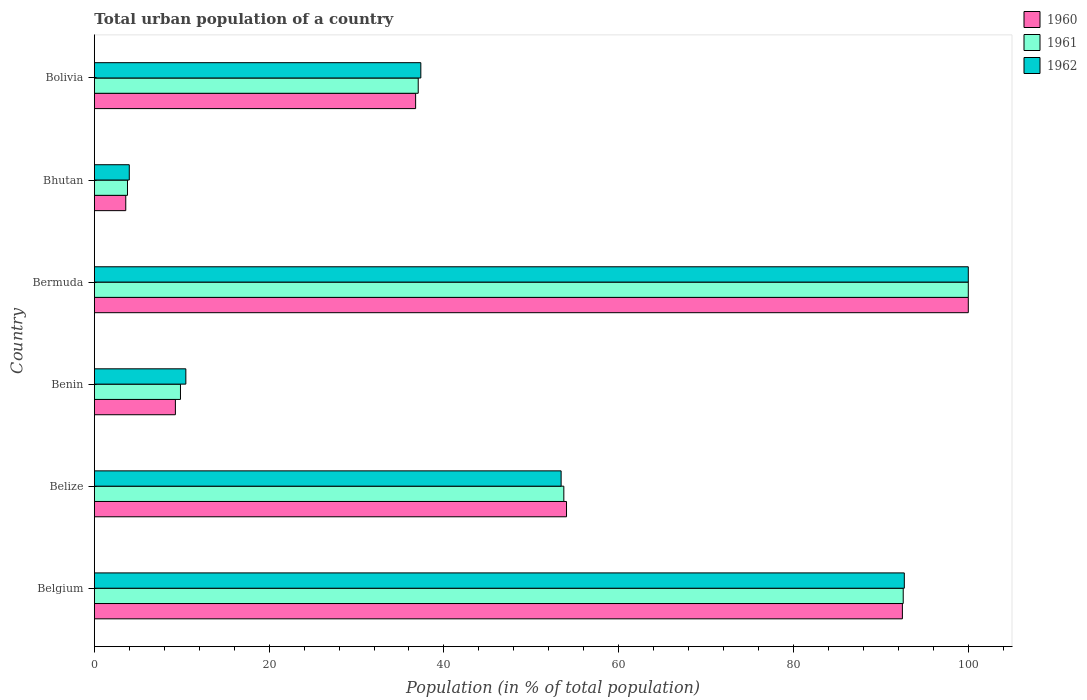How many different coloured bars are there?
Your answer should be very brief. 3. How many groups of bars are there?
Give a very brief answer. 6. Are the number of bars per tick equal to the number of legend labels?
Offer a terse response. Yes. Are the number of bars on each tick of the Y-axis equal?
Offer a very short reply. Yes. What is the label of the 4th group of bars from the top?
Make the answer very short. Benin. What is the urban population in 1961 in Belgium?
Ensure brevity in your answer.  92.55. Across all countries, what is the maximum urban population in 1960?
Your answer should be compact. 100. Across all countries, what is the minimum urban population in 1961?
Keep it short and to the point. 3.79. In which country was the urban population in 1960 maximum?
Give a very brief answer. Bermuda. In which country was the urban population in 1962 minimum?
Provide a short and direct response. Bhutan. What is the total urban population in 1960 in the graph?
Your answer should be very brief. 296.12. What is the difference between the urban population in 1962 in Belgium and that in Belize?
Make the answer very short. 39.27. What is the difference between the urban population in 1960 in Bolivia and the urban population in 1961 in Benin?
Offer a very short reply. 26.91. What is the average urban population in 1960 per country?
Keep it short and to the point. 49.35. What is the difference between the urban population in 1961 and urban population in 1960 in Belize?
Offer a terse response. -0.31. What is the ratio of the urban population in 1962 in Benin to that in Bolivia?
Your response must be concise. 0.28. Is the urban population in 1960 in Belgium less than that in Bhutan?
Offer a very short reply. No. What is the difference between the highest and the second highest urban population in 1962?
Your answer should be very brief. 7.32. What is the difference between the highest and the lowest urban population in 1961?
Your answer should be very brief. 96.21. In how many countries, is the urban population in 1960 greater than the average urban population in 1960 taken over all countries?
Keep it short and to the point. 3. Is the sum of the urban population in 1961 in Belize and Benin greater than the maximum urban population in 1962 across all countries?
Keep it short and to the point. No. What does the 1st bar from the top in Bhutan represents?
Offer a very short reply. 1962. Is it the case that in every country, the sum of the urban population in 1961 and urban population in 1962 is greater than the urban population in 1960?
Your answer should be very brief. Yes. How many bars are there?
Your response must be concise. 18. How many countries are there in the graph?
Provide a short and direct response. 6. What is the difference between two consecutive major ticks on the X-axis?
Provide a short and direct response. 20. Does the graph contain grids?
Provide a succinct answer. No. Where does the legend appear in the graph?
Offer a very short reply. Top right. How are the legend labels stacked?
Offer a terse response. Vertical. What is the title of the graph?
Your answer should be compact. Total urban population of a country. What is the label or title of the X-axis?
Make the answer very short. Population (in % of total population). What is the label or title of the Y-axis?
Ensure brevity in your answer.  Country. What is the Population (in % of total population) of 1960 in Belgium?
Keep it short and to the point. 92.46. What is the Population (in % of total population) of 1961 in Belgium?
Ensure brevity in your answer.  92.55. What is the Population (in % of total population) of 1962 in Belgium?
Ensure brevity in your answer.  92.68. What is the Population (in % of total population) in 1960 in Belize?
Your response must be concise. 54.03. What is the Population (in % of total population) in 1961 in Belize?
Give a very brief answer. 53.72. What is the Population (in % of total population) in 1962 in Belize?
Your answer should be compact. 53.41. What is the Population (in % of total population) of 1960 in Benin?
Offer a terse response. 9.28. What is the Population (in % of total population) in 1961 in Benin?
Offer a terse response. 9.86. What is the Population (in % of total population) in 1962 in Benin?
Provide a succinct answer. 10.47. What is the Population (in % of total population) in 1961 in Bermuda?
Your answer should be compact. 100. What is the Population (in % of total population) of 1962 in Bermuda?
Offer a terse response. 100. What is the Population (in % of total population) of 1960 in Bhutan?
Make the answer very short. 3.6. What is the Population (in % of total population) of 1961 in Bhutan?
Provide a short and direct response. 3.79. What is the Population (in % of total population) in 1962 in Bhutan?
Your answer should be very brief. 4. What is the Population (in % of total population) in 1960 in Bolivia?
Offer a very short reply. 36.76. What is the Population (in % of total population) in 1961 in Bolivia?
Your response must be concise. 37.06. What is the Population (in % of total population) in 1962 in Bolivia?
Keep it short and to the point. 37.36. Across all countries, what is the maximum Population (in % of total population) of 1960?
Provide a succinct answer. 100. Across all countries, what is the maximum Population (in % of total population) of 1961?
Provide a succinct answer. 100. Across all countries, what is the maximum Population (in % of total population) of 1962?
Provide a succinct answer. 100. Across all countries, what is the minimum Population (in % of total population) of 1960?
Ensure brevity in your answer.  3.6. Across all countries, what is the minimum Population (in % of total population) of 1961?
Your response must be concise. 3.79. Across all countries, what is the minimum Population (in % of total population) of 1962?
Keep it short and to the point. 4. What is the total Population (in % of total population) in 1960 in the graph?
Provide a succinct answer. 296.12. What is the total Population (in % of total population) of 1961 in the graph?
Provide a succinct answer. 296.98. What is the total Population (in % of total population) in 1962 in the graph?
Offer a terse response. 297.92. What is the difference between the Population (in % of total population) of 1960 in Belgium and that in Belize?
Provide a short and direct response. 38.43. What is the difference between the Population (in % of total population) of 1961 in Belgium and that in Belize?
Your answer should be very brief. 38.83. What is the difference between the Population (in % of total population) of 1962 in Belgium and that in Belize?
Make the answer very short. 39.27. What is the difference between the Population (in % of total population) in 1960 in Belgium and that in Benin?
Give a very brief answer. 83.19. What is the difference between the Population (in % of total population) of 1961 in Belgium and that in Benin?
Ensure brevity in your answer.  82.7. What is the difference between the Population (in % of total population) of 1962 in Belgium and that in Benin?
Provide a short and direct response. 82.21. What is the difference between the Population (in % of total population) of 1960 in Belgium and that in Bermuda?
Offer a very short reply. -7.54. What is the difference between the Population (in % of total population) of 1961 in Belgium and that in Bermuda?
Offer a very short reply. -7.45. What is the difference between the Population (in % of total population) of 1962 in Belgium and that in Bermuda?
Provide a short and direct response. -7.32. What is the difference between the Population (in % of total population) in 1960 in Belgium and that in Bhutan?
Make the answer very short. 88.86. What is the difference between the Population (in % of total population) in 1961 in Belgium and that in Bhutan?
Your answer should be very brief. 88.76. What is the difference between the Population (in % of total population) of 1962 in Belgium and that in Bhutan?
Make the answer very short. 88.68. What is the difference between the Population (in % of total population) in 1960 in Belgium and that in Bolivia?
Offer a very short reply. 55.7. What is the difference between the Population (in % of total population) of 1961 in Belgium and that in Bolivia?
Ensure brevity in your answer.  55.49. What is the difference between the Population (in % of total population) in 1962 in Belgium and that in Bolivia?
Offer a very short reply. 55.32. What is the difference between the Population (in % of total population) of 1960 in Belize and that in Benin?
Your answer should be very brief. 44.75. What is the difference between the Population (in % of total population) of 1961 in Belize and that in Benin?
Keep it short and to the point. 43.86. What is the difference between the Population (in % of total population) of 1962 in Belize and that in Benin?
Keep it short and to the point. 42.94. What is the difference between the Population (in % of total population) in 1960 in Belize and that in Bermuda?
Keep it short and to the point. -45.97. What is the difference between the Population (in % of total population) of 1961 in Belize and that in Bermuda?
Your response must be concise. -46.28. What is the difference between the Population (in % of total population) of 1962 in Belize and that in Bermuda?
Ensure brevity in your answer.  -46.59. What is the difference between the Population (in % of total population) in 1960 in Belize and that in Bhutan?
Your answer should be compact. 50.43. What is the difference between the Population (in % of total population) of 1961 in Belize and that in Bhutan?
Your answer should be compact. 49.93. What is the difference between the Population (in % of total population) in 1962 in Belize and that in Bhutan?
Your response must be concise. 49.41. What is the difference between the Population (in % of total population) of 1960 in Belize and that in Bolivia?
Keep it short and to the point. 17.27. What is the difference between the Population (in % of total population) in 1961 in Belize and that in Bolivia?
Make the answer very short. 16.66. What is the difference between the Population (in % of total population) in 1962 in Belize and that in Bolivia?
Keep it short and to the point. 16.05. What is the difference between the Population (in % of total population) in 1960 in Benin and that in Bermuda?
Provide a short and direct response. -90.72. What is the difference between the Population (in % of total population) in 1961 in Benin and that in Bermuda?
Provide a short and direct response. -90.14. What is the difference between the Population (in % of total population) in 1962 in Benin and that in Bermuda?
Provide a short and direct response. -89.53. What is the difference between the Population (in % of total population) in 1960 in Benin and that in Bhutan?
Your answer should be very brief. 5.68. What is the difference between the Population (in % of total population) in 1961 in Benin and that in Bhutan?
Keep it short and to the point. 6.06. What is the difference between the Population (in % of total population) of 1962 in Benin and that in Bhutan?
Make the answer very short. 6.47. What is the difference between the Population (in % of total population) of 1960 in Benin and that in Bolivia?
Offer a very short reply. -27.49. What is the difference between the Population (in % of total population) in 1961 in Benin and that in Bolivia?
Ensure brevity in your answer.  -27.2. What is the difference between the Population (in % of total population) of 1962 in Benin and that in Bolivia?
Offer a very short reply. -26.89. What is the difference between the Population (in % of total population) in 1960 in Bermuda and that in Bhutan?
Keep it short and to the point. 96.4. What is the difference between the Population (in % of total population) of 1961 in Bermuda and that in Bhutan?
Give a very brief answer. 96.21. What is the difference between the Population (in % of total population) in 1962 in Bermuda and that in Bhutan?
Keep it short and to the point. 96. What is the difference between the Population (in % of total population) in 1960 in Bermuda and that in Bolivia?
Provide a short and direct response. 63.24. What is the difference between the Population (in % of total population) in 1961 in Bermuda and that in Bolivia?
Provide a succinct answer. 62.94. What is the difference between the Population (in % of total population) in 1962 in Bermuda and that in Bolivia?
Make the answer very short. 62.64. What is the difference between the Population (in % of total population) in 1960 in Bhutan and that in Bolivia?
Offer a terse response. -33.17. What is the difference between the Population (in % of total population) in 1961 in Bhutan and that in Bolivia?
Offer a terse response. -33.27. What is the difference between the Population (in % of total population) of 1962 in Bhutan and that in Bolivia?
Ensure brevity in your answer.  -33.36. What is the difference between the Population (in % of total population) of 1960 in Belgium and the Population (in % of total population) of 1961 in Belize?
Provide a succinct answer. 38.74. What is the difference between the Population (in % of total population) of 1960 in Belgium and the Population (in % of total population) of 1962 in Belize?
Give a very brief answer. 39.05. What is the difference between the Population (in % of total population) in 1961 in Belgium and the Population (in % of total population) in 1962 in Belize?
Offer a very short reply. 39.14. What is the difference between the Population (in % of total population) in 1960 in Belgium and the Population (in % of total population) in 1961 in Benin?
Your answer should be compact. 82.6. What is the difference between the Population (in % of total population) of 1960 in Belgium and the Population (in % of total population) of 1962 in Benin?
Provide a short and direct response. 81.99. What is the difference between the Population (in % of total population) in 1961 in Belgium and the Population (in % of total population) in 1962 in Benin?
Provide a short and direct response. 82.08. What is the difference between the Population (in % of total population) in 1960 in Belgium and the Population (in % of total population) in 1961 in Bermuda?
Keep it short and to the point. -7.54. What is the difference between the Population (in % of total population) of 1960 in Belgium and the Population (in % of total population) of 1962 in Bermuda?
Provide a succinct answer. -7.54. What is the difference between the Population (in % of total population) in 1961 in Belgium and the Population (in % of total population) in 1962 in Bermuda?
Give a very brief answer. -7.45. What is the difference between the Population (in % of total population) in 1960 in Belgium and the Population (in % of total population) in 1961 in Bhutan?
Your answer should be compact. 88.67. What is the difference between the Population (in % of total population) of 1960 in Belgium and the Population (in % of total population) of 1962 in Bhutan?
Make the answer very short. 88.46. What is the difference between the Population (in % of total population) of 1961 in Belgium and the Population (in % of total population) of 1962 in Bhutan?
Your response must be concise. 88.56. What is the difference between the Population (in % of total population) of 1960 in Belgium and the Population (in % of total population) of 1961 in Bolivia?
Your answer should be very brief. 55.4. What is the difference between the Population (in % of total population) of 1960 in Belgium and the Population (in % of total population) of 1962 in Bolivia?
Ensure brevity in your answer.  55.1. What is the difference between the Population (in % of total population) in 1961 in Belgium and the Population (in % of total population) in 1962 in Bolivia?
Your answer should be very brief. 55.2. What is the difference between the Population (in % of total population) in 1960 in Belize and the Population (in % of total population) in 1961 in Benin?
Make the answer very short. 44.17. What is the difference between the Population (in % of total population) of 1960 in Belize and the Population (in % of total population) of 1962 in Benin?
Your answer should be compact. 43.56. What is the difference between the Population (in % of total population) in 1961 in Belize and the Population (in % of total population) in 1962 in Benin?
Your response must be concise. 43.25. What is the difference between the Population (in % of total population) of 1960 in Belize and the Population (in % of total population) of 1961 in Bermuda?
Make the answer very short. -45.97. What is the difference between the Population (in % of total population) in 1960 in Belize and the Population (in % of total population) in 1962 in Bermuda?
Offer a very short reply. -45.97. What is the difference between the Population (in % of total population) in 1961 in Belize and the Population (in % of total population) in 1962 in Bermuda?
Offer a terse response. -46.28. What is the difference between the Population (in % of total population) of 1960 in Belize and the Population (in % of total population) of 1961 in Bhutan?
Give a very brief answer. 50.24. What is the difference between the Population (in % of total population) in 1960 in Belize and the Population (in % of total population) in 1962 in Bhutan?
Keep it short and to the point. 50.03. What is the difference between the Population (in % of total population) in 1961 in Belize and the Population (in % of total population) in 1962 in Bhutan?
Your answer should be very brief. 49.72. What is the difference between the Population (in % of total population) in 1960 in Belize and the Population (in % of total population) in 1961 in Bolivia?
Give a very brief answer. 16.97. What is the difference between the Population (in % of total population) of 1960 in Belize and the Population (in % of total population) of 1962 in Bolivia?
Offer a terse response. 16.67. What is the difference between the Population (in % of total population) in 1961 in Belize and the Population (in % of total population) in 1962 in Bolivia?
Ensure brevity in your answer.  16.36. What is the difference between the Population (in % of total population) in 1960 in Benin and the Population (in % of total population) in 1961 in Bermuda?
Your answer should be very brief. -90.72. What is the difference between the Population (in % of total population) in 1960 in Benin and the Population (in % of total population) in 1962 in Bermuda?
Make the answer very short. -90.72. What is the difference between the Population (in % of total population) of 1961 in Benin and the Population (in % of total population) of 1962 in Bermuda?
Your response must be concise. -90.14. What is the difference between the Population (in % of total population) in 1960 in Benin and the Population (in % of total population) in 1961 in Bhutan?
Offer a terse response. 5.48. What is the difference between the Population (in % of total population) of 1960 in Benin and the Population (in % of total population) of 1962 in Bhutan?
Offer a very short reply. 5.28. What is the difference between the Population (in % of total population) of 1961 in Benin and the Population (in % of total population) of 1962 in Bhutan?
Your answer should be very brief. 5.86. What is the difference between the Population (in % of total population) in 1960 in Benin and the Population (in % of total population) in 1961 in Bolivia?
Your answer should be very brief. -27.78. What is the difference between the Population (in % of total population) of 1960 in Benin and the Population (in % of total population) of 1962 in Bolivia?
Your answer should be compact. -28.08. What is the difference between the Population (in % of total population) of 1961 in Benin and the Population (in % of total population) of 1962 in Bolivia?
Offer a very short reply. -27.5. What is the difference between the Population (in % of total population) of 1960 in Bermuda and the Population (in % of total population) of 1961 in Bhutan?
Offer a very short reply. 96.21. What is the difference between the Population (in % of total population) of 1960 in Bermuda and the Population (in % of total population) of 1962 in Bhutan?
Give a very brief answer. 96. What is the difference between the Population (in % of total population) in 1961 in Bermuda and the Population (in % of total population) in 1962 in Bhutan?
Keep it short and to the point. 96. What is the difference between the Population (in % of total population) in 1960 in Bermuda and the Population (in % of total population) in 1961 in Bolivia?
Your answer should be compact. 62.94. What is the difference between the Population (in % of total population) of 1960 in Bermuda and the Population (in % of total population) of 1962 in Bolivia?
Your answer should be compact. 62.64. What is the difference between the Population (in % of total population) of 1961 in Bermuda and the Population (in % of total population) of 1962 in Bolivia?
Provide a succinct answer. 62.64. What is the difference between the Population (in % of total population) in 1960 in Bhutan and the Population (in % of total population) in 1961 in Bolivia?
Your response must be concise. -33.46. What is the difference between the Population (in % of total population) of 1960 in Bhutan and the Population (in % of total population) of 1962 in Bolivia?
Provide a short and direct response. -33.76. What is the difference between the Population (in % of total population) of 1961 in Bhutan and the Population (in % of total population) of 1962 in Bolivia?
Your answer should be very brief. -33.56. What is the average Population (in % of total population) in 1960 per country?
Offer a terse response. 49.35. What is the average Population (in % of total population) in 1961 per country?
Keep it short and to the point. 49.5. What is the average Population (in % of total population) of 1962 per country?
Ensure brevity in your answer.  49.65. What is the difference between the Population (in % of total population) of 1960 and Population (in % of total population) of 1961 in Belgium?
Provide a succinct answer. -0.09. What is the difference between the Population (in % of total population) in 1960 and Population (in % of total population) in 1962 in Belgium?
Provide a short and direct response. -0.22. What is the difference between the Population (in % of total population) of 1961 and Population (in % of total population) of 1962 in Belgium?
Your answer should be very brief. -0.12. What is the difference between the Population (in % of total population) of 1960 and Population (in % of total population) of 1961 in Belize?
Your answer should be very brief. 0.31. What is the difference between the Population (in % of total population) of 1960 and Population (in % of total population) of 1962 in Belize?
Your answer should be very brief. 0.62. What is the difference between the Population (in % of total population) in 1961 and Population (in % of total population) in 1962 in Belize?
Your response must be concise. 0.31. What is the difference between the Population (in % of total population) in 1960 and Population (in % of total population) in 1961 in Benin?
Provide a succinct answer. -0.58. What is the difference between the Population (in % of total population) of 1960 and Population (in % of total population) of 1962 in Benin?
Provide a short and direct response. -1.2. What is the difference between the Population (in % of total population) of 1961 and Population (in % of total population) of 1962 in Benin?
Your answer should be very brief. -0.61. What is the difference between the Population (in % of total population) of 1960 and Population (in % of total population) of 1961 in Bhutan?
Offer a very short reply. -0.2. What is the difference between the Population (in % of total population) of 1960 and Population (in % of total population) of 1962 in Bhutan?
Your response must be concise. -0.4. What is the difference between the Population (in % of total population) of 1961 and Population (in % of total population) of 1962 in Bhutan?
Your answer should be very brief. -0.21. What is the difference between the Population (in % of total population) in 1960 and Population (in % of total population) in 1961 in Bolivia?
Your answer should be compact. -0.3. What is the difference between the Population (in % of total population) of 1960 and Population (in % of total population) of 1962 in Bolivia?
Provide a short and direct response. -0.59. What is the difference between the Population (in % of total population) of 1961 and Population (in % of total population) of 1962 in Bolivia?
Ensure brevity in your answer.  -0.3. What is the ratio of the Population (in % of total population) in 1960 in Belgium to that in Belize?
Your response must be concise. 1.71. What is the ratio of the Population (in % of total population) in 1961 in Belgium to that in Belize?
Your answer should be very brief. 1.72. What is the ratio of the Population (in % of total population) of 1962 in Belgium to that in Belize?
Make the answer very short. 1.74. What is the ratio of the Population (in % of total population) in 1960 in Belgium to that in Benin?
Ensure brevity in your answer.  9.97. What is the ratio of the Population (in % of total population) in 1961 in Belgium to that in Benin?
Provide a succinct answer. 9.39. What is the ratio of the Population (in % of total population) of 1962 in Belgium to that in Benin?
Provide a succinct answer. 8.85. What is the ratio of the Population (in % of total population) in 1960 in Belgium to that in Bermuda?
Your response must be concise. 0.92. What is the ratio of the Population (in % of total population) of 1961 in Belgium to that in Bermuda?
Your answer should be very brief. 0.93. What is the ratio of the Population (in % of total population) in 1962 in Belgium to that in Bermuda?
Offer a very short reply. 0.93. What is the ratio of the Population (in % of total population) in 1960 in Belgium to that in Bhutan?
Your answer should be compact. 25.71. What is the ratio of the Population (in % of total population) of 1961 in Belgium to that in Bhutan?
Offer a very short reply. 24.41. What is the ratio of the Population (in % of total population) in 1962 in Belgium to that in Bhutan?
Make the answer very short. 23.18. What is the ratio of the Population (in % of total population) of 1960 in Belgium to that in Bolivia?
Give a very brief answer. 2.52. What is the ratio of the Population (in % of total population) in 1961 in Belgium to that in Bolivia?
Your answer should be very brief. 2.5. What is the ratio of the Population (in % of total population) in 1962 in Belgium to that in Bolivia?
Your answer should be very brief. 2.48. What is the ratio of the Population (in % of total population) in 1960 in Belize to that in Benin?
Your answer should be compact. 5.83. What is the ratio of the Population (in % of total population) of 1961 in Belize to that in Benin?
Your answer should be compact. 5.45. What is the ratio of the Population (in % of total population) in 1962 in Belize to that in Benin?
Provide a short and direct response. 5.1. What is the ratio of the Population (in % of total population) of 1960 in Belize to that in Bermuda?
Your response must be concise. 0.54. What is the ratio of the Population (in % of total population) of 1961 in Belize to that in Bermuda?
Your response must be concise. 0.54. What is the ratio of the Population (in % of total population) of 1962 in Belize to that in Bermuda?
Provide a succinct answer. 0.53. What is the ratio of the Population (in % of total population) in 1960 in Belize to that in Bhutan?
Your response must be concise. 15.02. What is the ratio of the Population (in % of total population) of 1961 in Belize to that in Bhutan?
Offer a terse response. 14.17. What is the ratio of the Population (in % of total population) in 1962 in Belize to that in Bhutan?
Make the answer very short. 13.36. What is the ratio of the Population (in % of total population) of 1960 in Belize to that in Bolivia?
Provide a succinct answer. 1.47. What is the ratio of the Population (in % of total population) in 1961 in Belize to that in Bolivia?
Make the answer very short. 1.45. What is the ratio of the Population (in % of total population) of 1962 in Belize to that in Bolivia?
Offer a terse response. 1.43. What is the ratio of the Population (in % of total population) in 1960 in Benin to that in Bermuda?
Your answer should be very brief. 0.09. What is the ratio of the Population (in % of total population) in 1961 in Benin to that in Bermuda?
Your answer should be compact. 0.1. What is the ratio of the Population (in % of total population) in 1962 in Benin to that in Bermuda?
Provide a short and direct response. 0.1. What is the ratio of the Population (in % of total population) in 1960 in Benin to that in Bhutan?
Provide a succinct answer. 2.58. What is the ratio of the Population (in % of total population) in 1961 in Benin to that in Bhutan?
Your answer should be compact. 2.6. What is the ratio of the Population (in % of total population) of 1962 in Benin to that in Bhutan?
Your answer should be compact. 2.62. What is the ratio of the Population (in % of total population) of 1960 in Benin to that in Bolivia?
Provide a succinct answer. 0.25. What is the ratio of the Population (in % of total population) of 1961 in Benin to that in Bolivia?
Provide a succinct answer. 0.27. What is the ratio of the Population (in % of total population) in 1962 in Benin to that in Bolivia?
Your answer should be very brief. 0.28. What is the ratio of the Population (in % of total population) in 1960 in Bermuda to that in Bhutan?
Offer a very short reply. 27.81. What is the ratio of the Population (in % of total population) of 1961 in Bermuda to that in Bhutan?
Offer a terse response. 26.37. What is the ratio of the Population (in % of total population) of 1962 in Bermuda to that in Bhutan?
Your answer should be compact. 25.01. What is the ratio of the Population (in % of total population) of 1960 in Bermuda to that in Bolivia?
Provide a short and direct response. 2.72. What is the ratio of the Population (in % of total population) in 1961 in Bermuda to that in Bolivia?
Ensure brevity in your answer.  2.7. What is the ratio of the Population (in % of total population) of 1962 in Bermuda to that in Bolivia?
Provide a short and direct response. 2.68. What is the ratio of the Population (in % of total population) of 1960 in Bhutan to that in Bolivia?
Give a very brief answer. 0.1. What is the ratio of the Population (in % of total population) of 1961 in Bhutan to that in Bolivia?
Offer a very short reply. 0.1. What is the ratio of the Population (in % of total population) of 1962 in Bhutan to that in Bolivia?
Offer a very short reply. 0.11. What is the difference between the highest and the second highest Population (in % of total population) in 1960?
Your answer should be compact. 7.54. What is the difference between the highest and the second highest Population (in % of total population) of 1961?
Your response must be concise. 7.45. What is the difference between the highest and the second highest Population (in % of total population) in 1962?
Provide a short and direct response. 7.32. What is the difference between the highest and the lowest Population (in % of total population) in 1960?
Make the answer very short. 96.4. What is the difference between the highest and the lowest Population (in % of total population) of 1961?
Offer a very short reply. 96.21. What is the difference between the highest and the lowest Population (in % of total population) in 1962?
Provide a short and direct response. 96. 